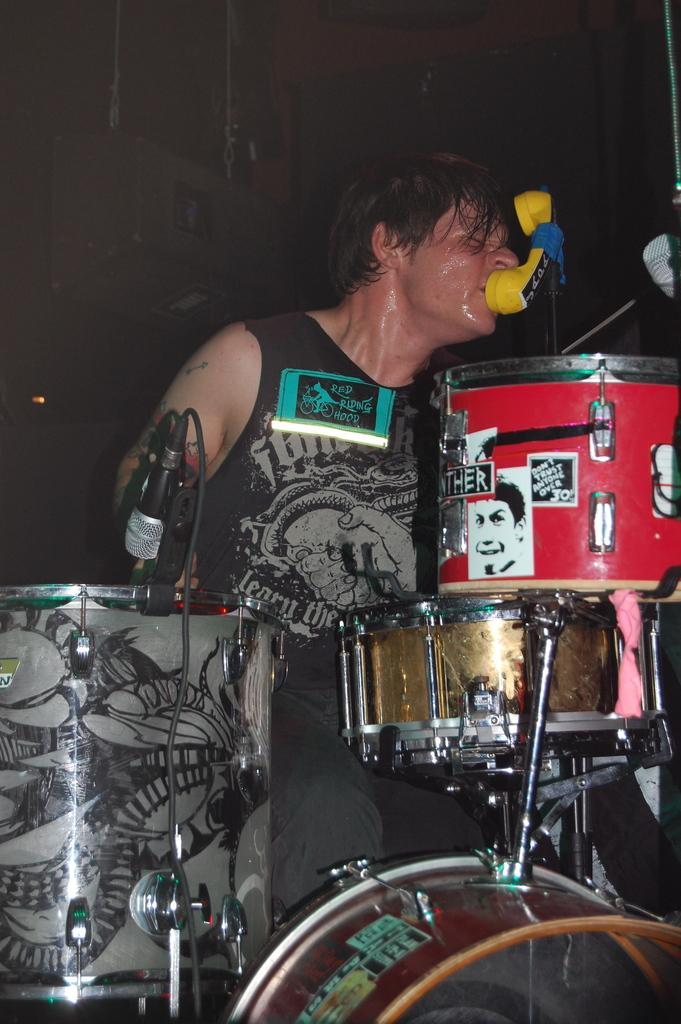What is the main subject of the image? There is a person in the image. What is the person wearing? The person is wearing a black dress. What is the person doing in the image? The person is sitting. What other objects are present in the image? There are musical instruments and a microphone with a cable attached to it on the left side of the image. Can you tell me how many sails are visible in the image? There are no sails present in the image. What type of cast is the person in the image a part of? The image does not provide any information about the person being part of a cast or any theatrical performance. 